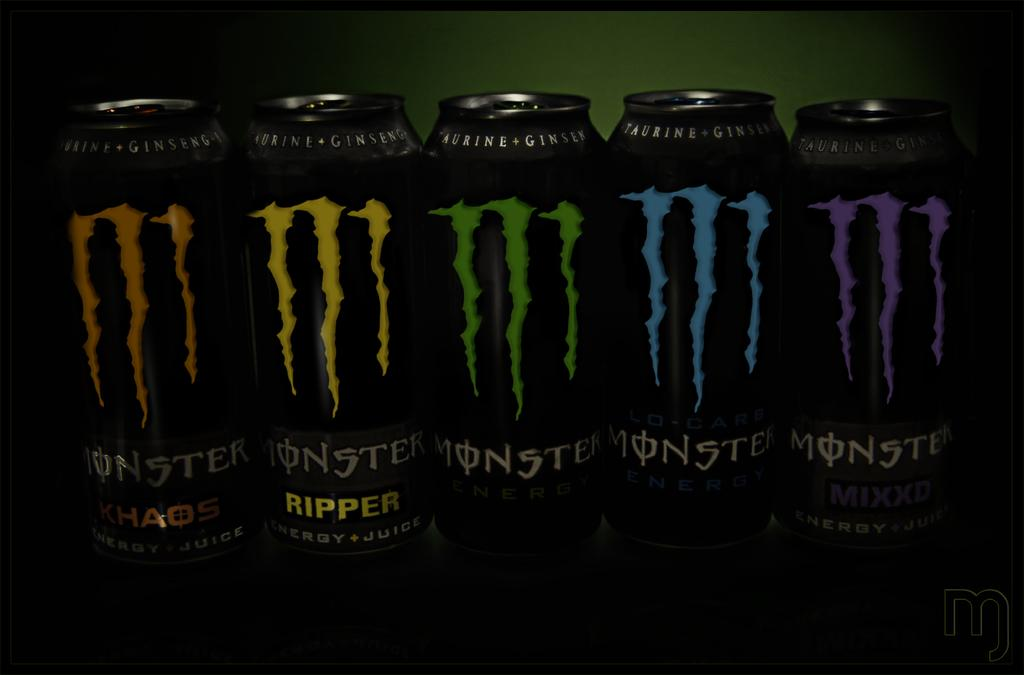<image>
Provide a brief description of the given image. One of the cans has the word "ripper" on it 